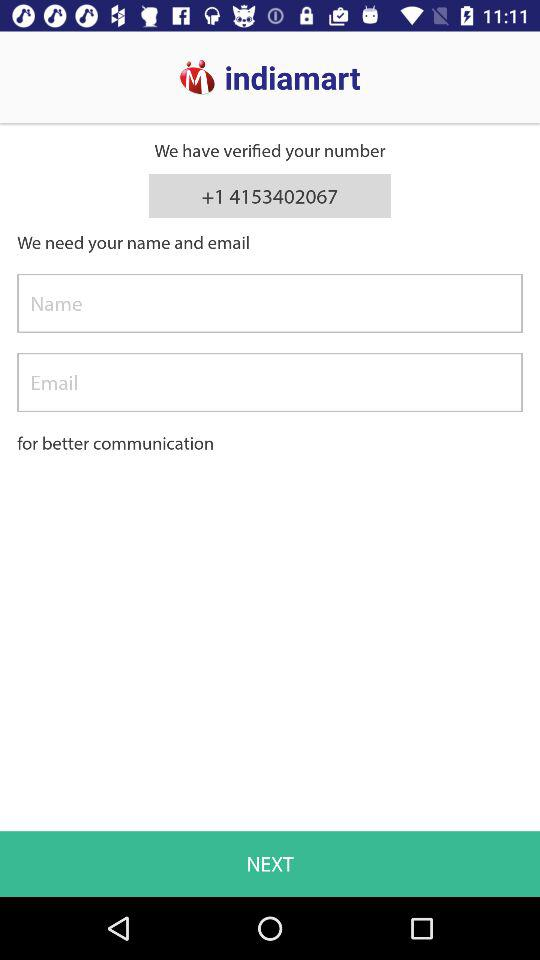How many text inputs are there after the text 'We need your name and email'?
Answer the question using a single word or phrase. 2 